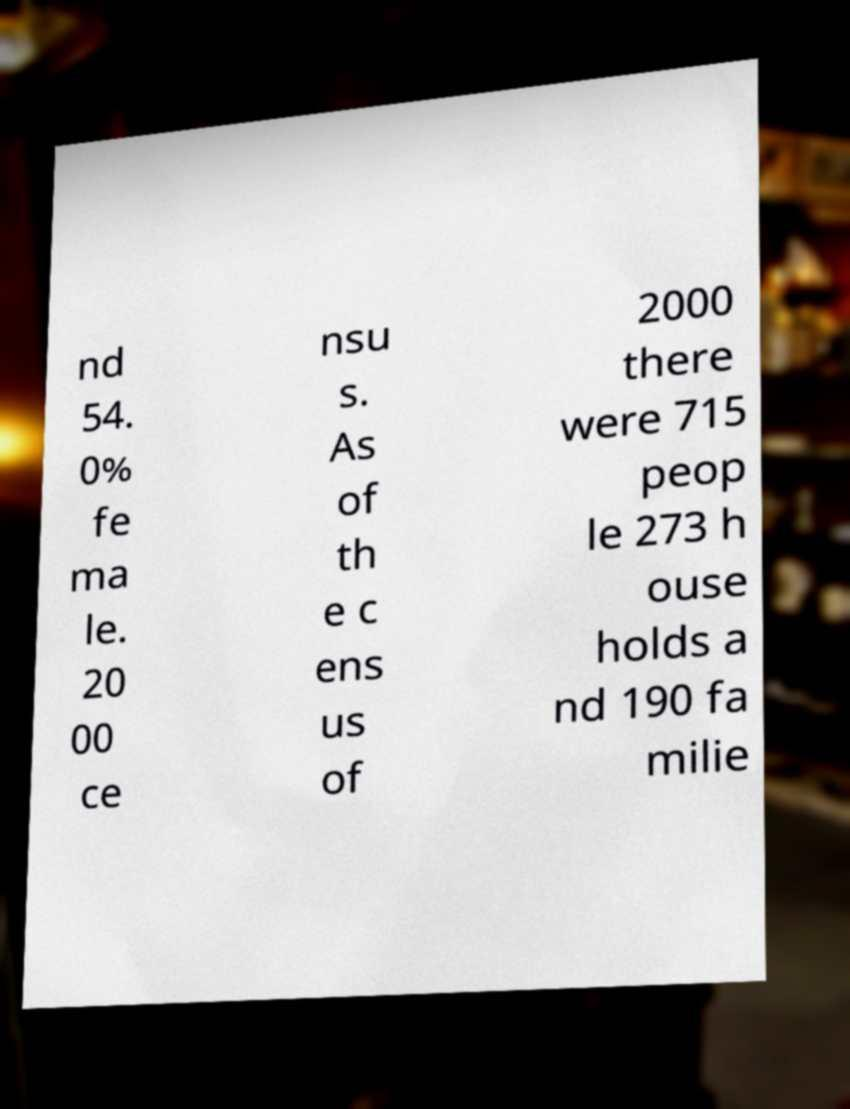What messages or text are displayed in this image? I need them in a readable, typed format. nd 54. 0% fe ma le. 20 00 ce nsu s. As of th e c ens us of 2000 there were 715 peop le 273 h ouse holds a nd 190 fa milie 